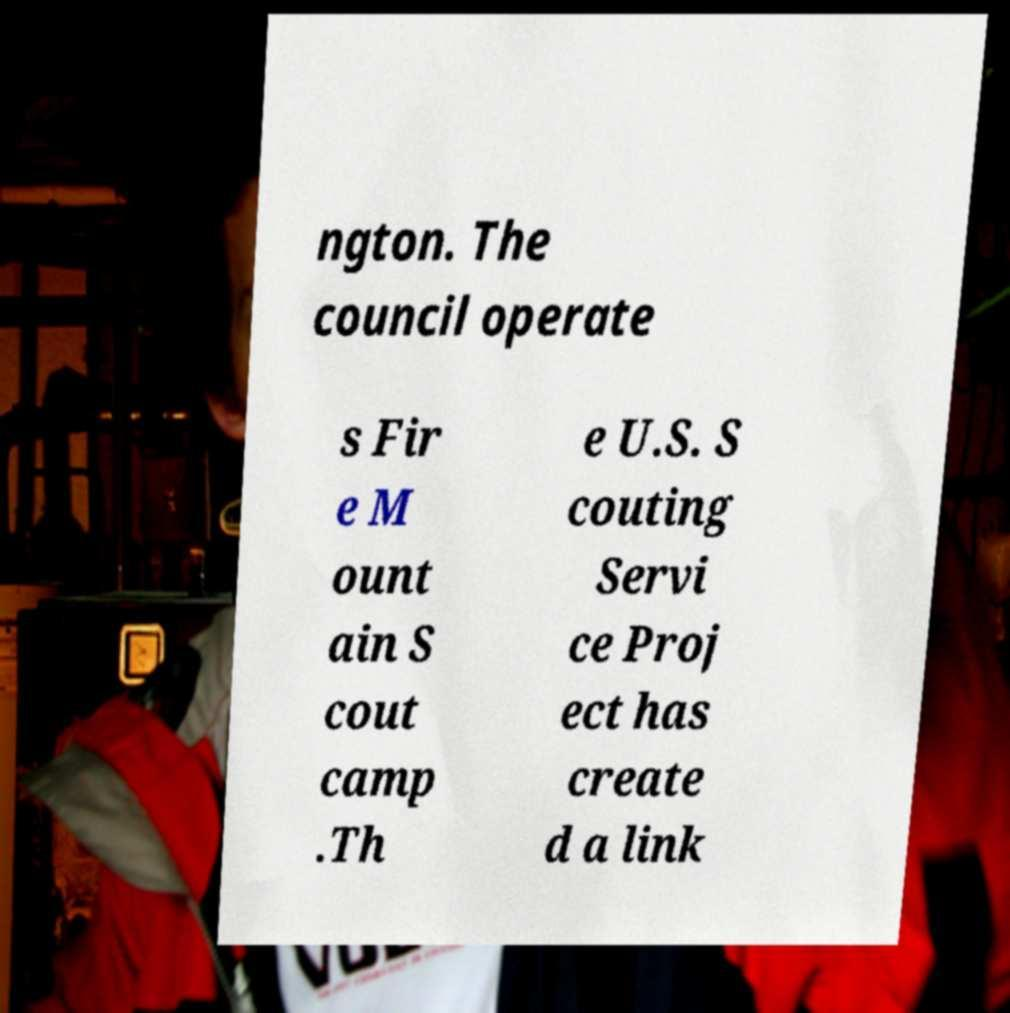I need the written content from this picture converted into text. Can you do that? ngton. The council operate s Fir e M ount ain S cout camp .Th e U.S. S couting Servi ce Proj ect has create d a link 